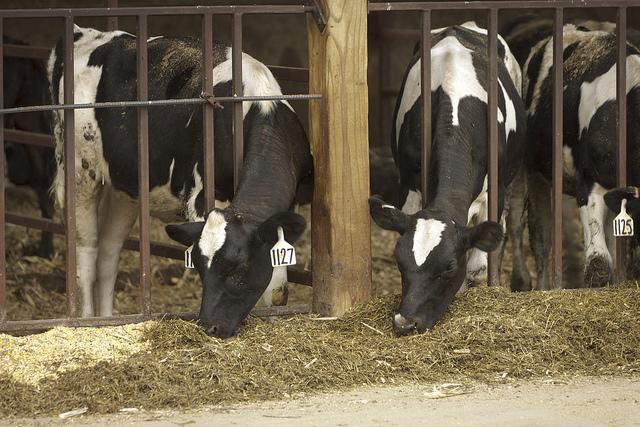Why do dairy cows have tags on their ears? Dairy cows have tags on their ears for identification purposes. These tags help farmers keep track of each cow's health, milk production, and other vital information. 